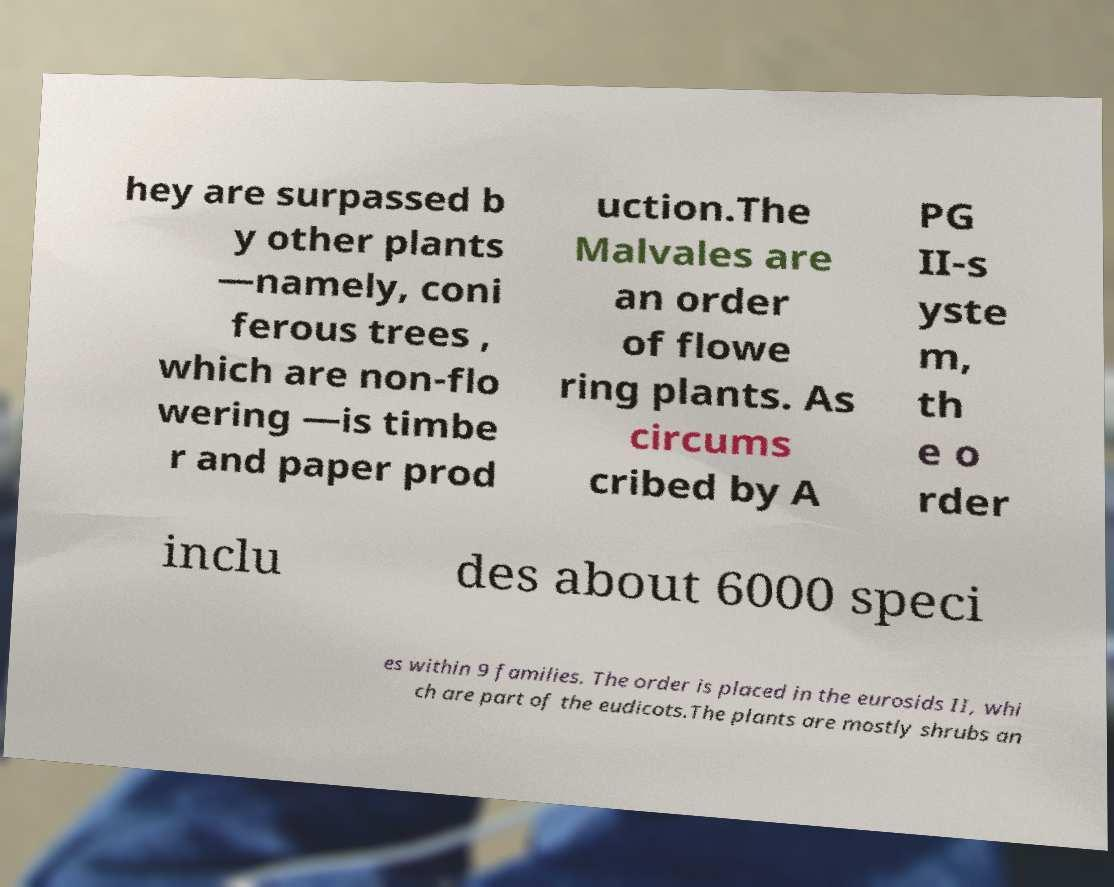Can you read and provide the text displayed in the image?This photo seems to have some interesting text. Can you extract and type it out for me? hey are surpassed b y other plants —namely, coni ferous trees , which are non-flo wering —is timbe r and paper prod uction.The Malvales are an order of flowe ring plants. As circums cribed by A PG II-s yste m, th e o rder inclu des about 6000 speci es within 9 families. The order is placed in the eurosids II, whi ch are part of the eudicots.The plants are mostly shrubs an 